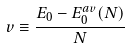Convert formula to latex. <formula><loc_0><loc_0><loc_500><loc_500>v \equiv \frac { E _ { 0 } - E _ { 0 } ^ { a v } ( N ) } { N }</formula> 